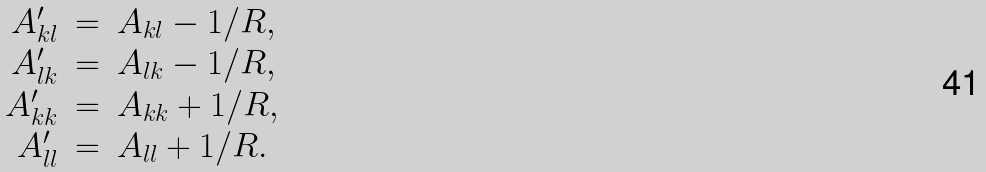Convert formula to latex. <formula><loc_0><loc_0><loc_500><loc_500>\begin{array} { r c l } A _ { k l } ^ { \prime } & = & A _ { k l } - 1 / R , \\ A _ { l k } ^ { \prime } & = & A _ { l k } - 1 / R , \\ A _ { k k } ^ { \prime } & = & A _ { k k } + 1 / R , \\ A _ { l l } ^ { \prime } & = & A _ { l l } + 1 / R . \end{array}</formula> 